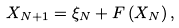Convert formula to latex. <formula><loc_0><loc_0><loc_500><loc_500>X _ { N + 1 } = \xi _ { N } + F \left ( X _ { N } \right ) ,</formula> 